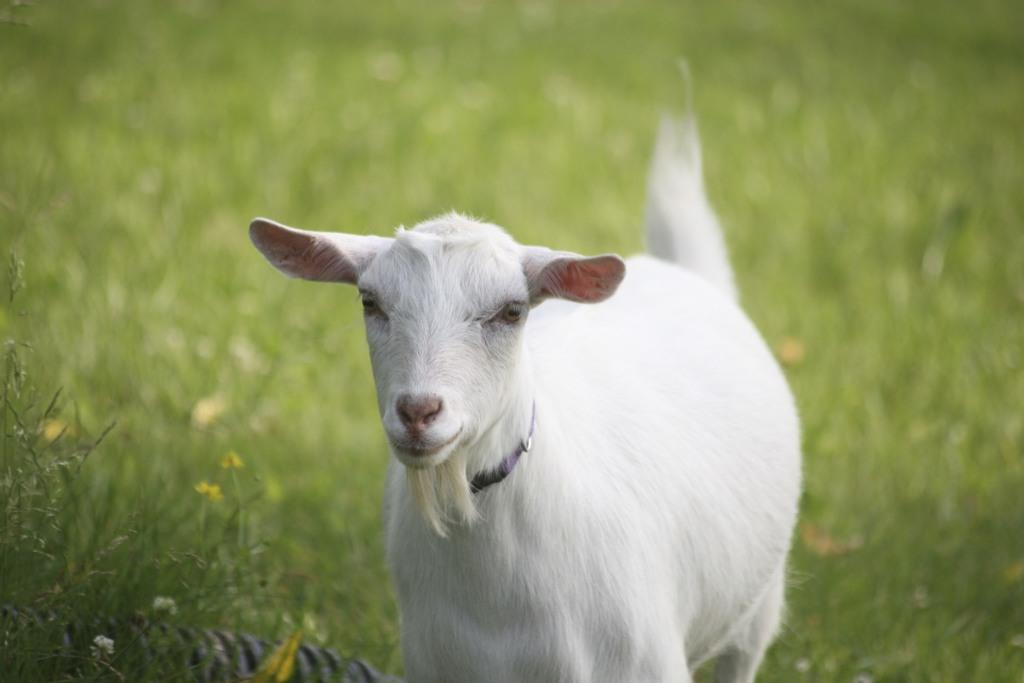What is the main subject in the center of the image? There is a lamb in the center of the image. What type of surface can be seen in the background of the image? The ground is visible in the background of the image. What is the ground covered with? The ground is covered with grass. What type of glove is the lamb wearing in the image? There is no glove present in the image, and the lamb is not wearing any clothing. 